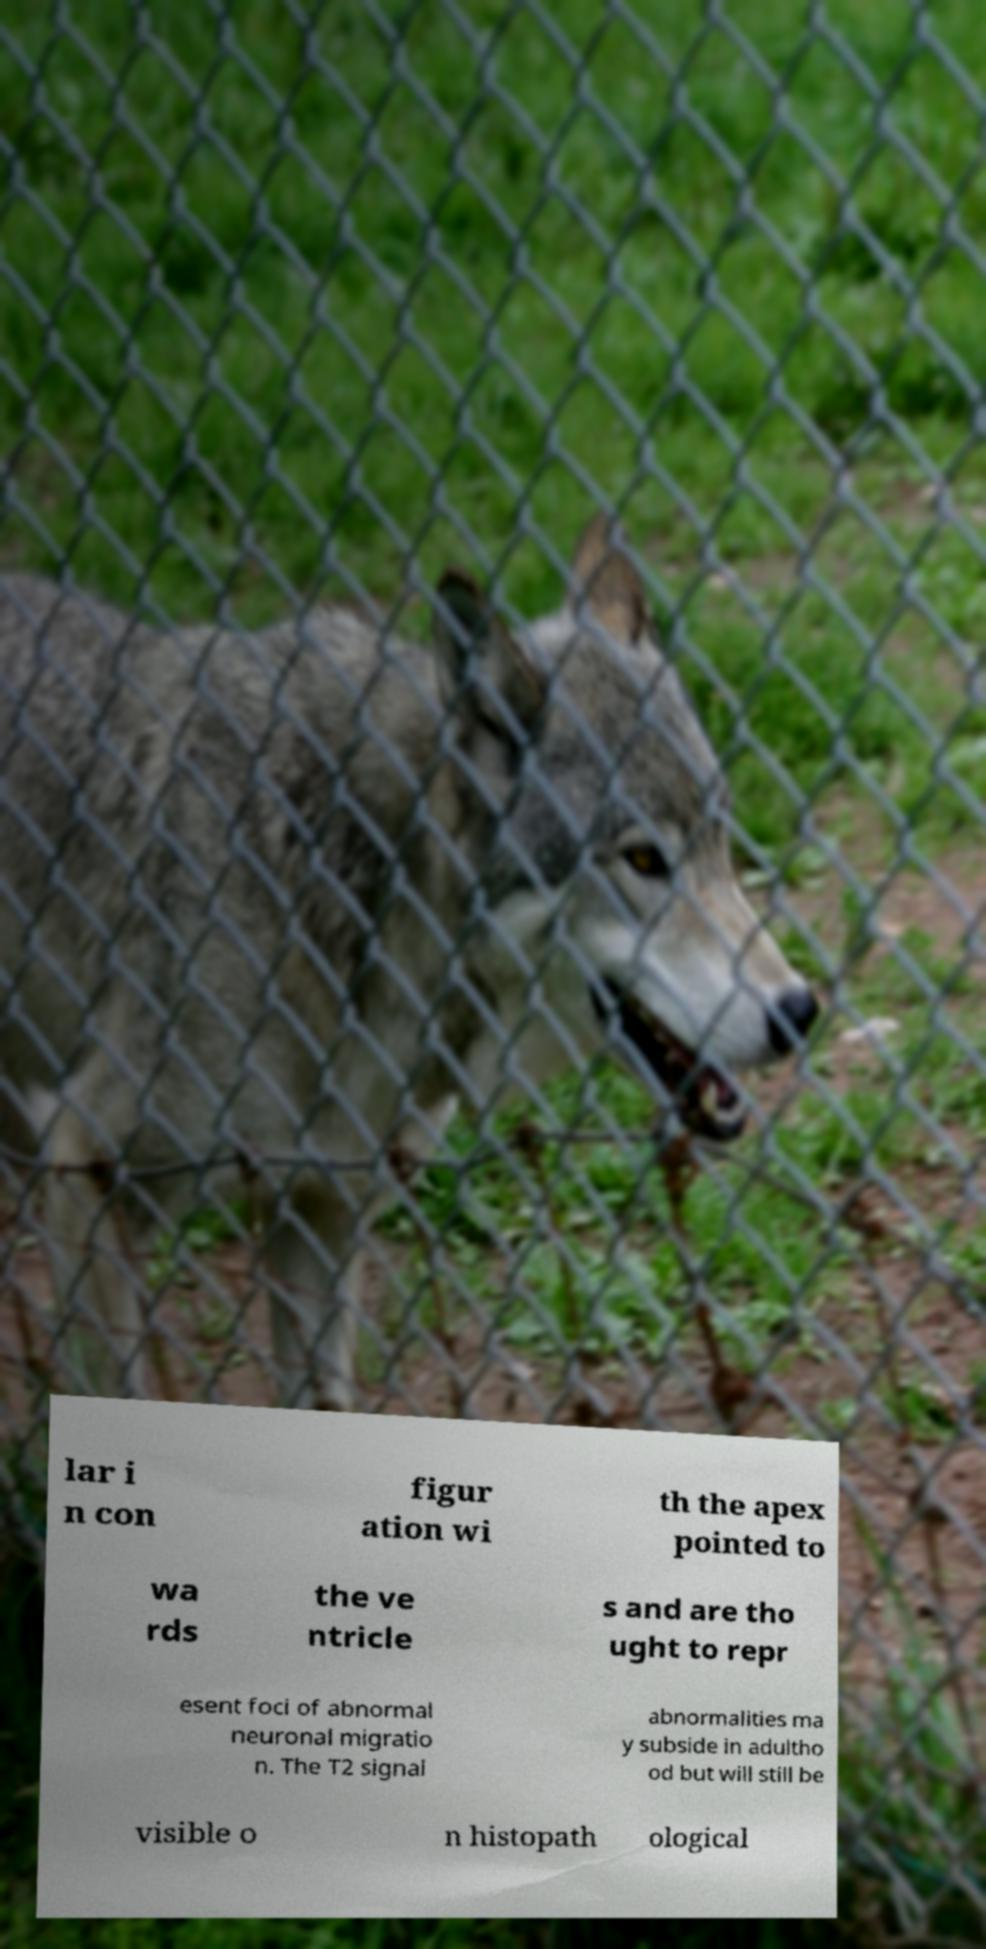Please identify and transcribe the text found in this image. lar i n con figur ation wi th the apex pointed to wa rds the ve ntricle s and are tho ught to repr esent foci of abnormal neuronal migratio n. The T2 signal abnormalities ma y subside in adultho od but will still be visible o n histopath ological 